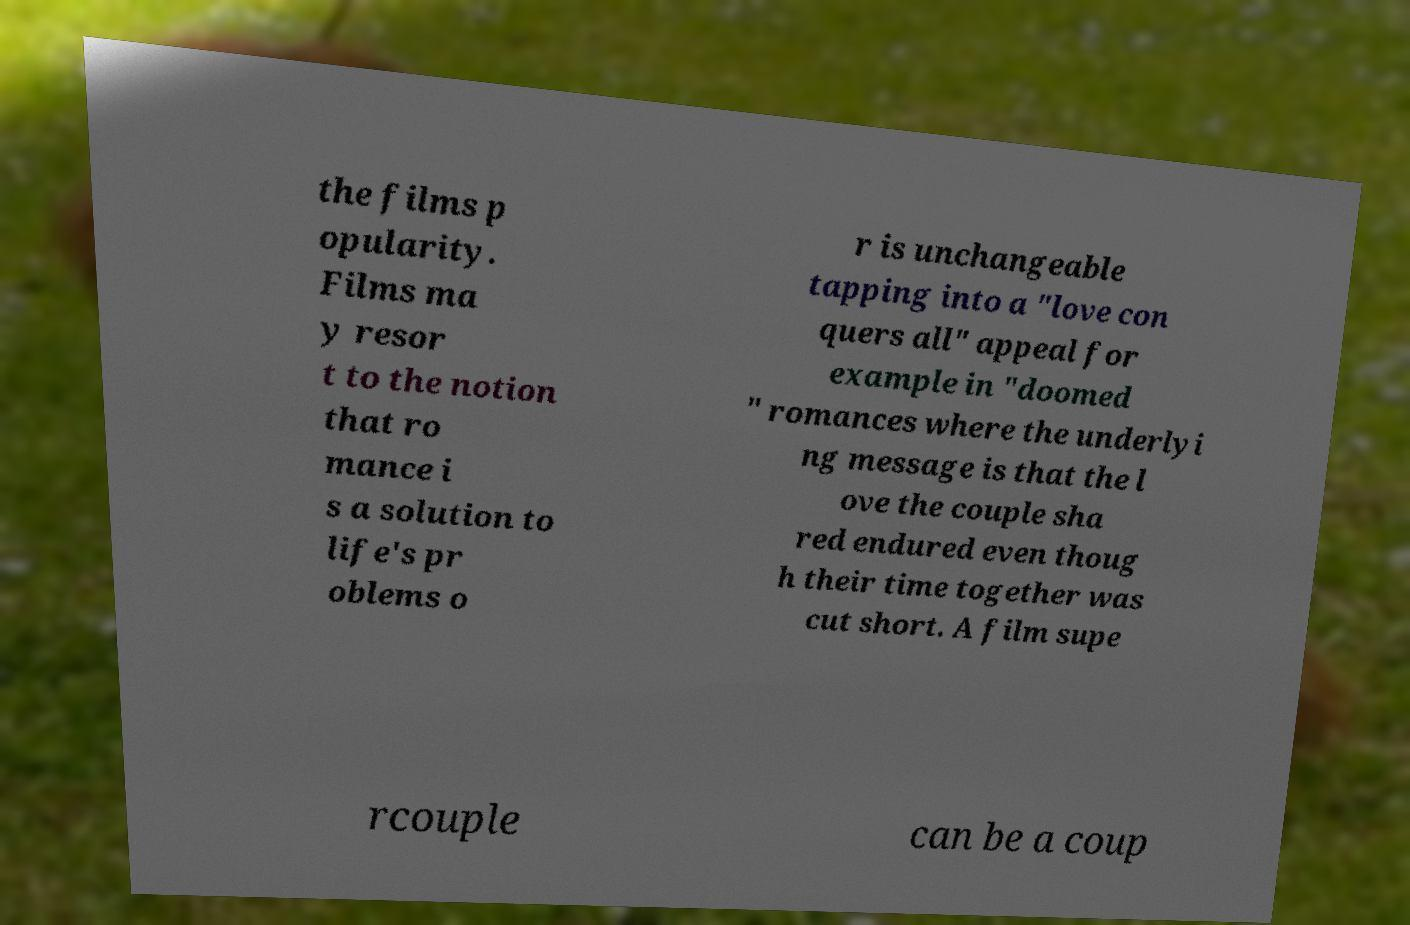Can you read and provide the text displayed in the image?This photo seems to have some interesting text. Can you extract and type it out for me? the films p opularity. Films ma y resor t to the notion that ro mance i s a solution to life's pr oblems o r is unchangeable tapping into a "love con quers all" appeal for example in "doomed " romances where the underlyi ng message is that the l ove the couple sha red endured even thoug h their time together was cut short. A film supe rcouple can be a coup 